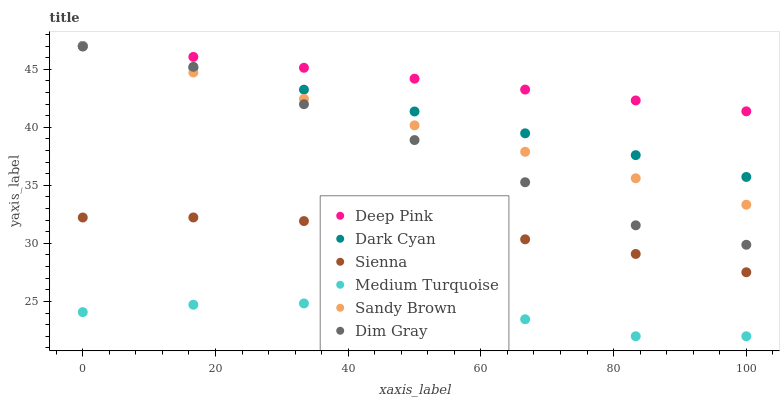Does Medium Turquoise have the minimum area under the curve?
Answer yes or no. Yes. Does Deep Pink have the maximum area under the curve?
Answer yes or no. Yes. Does Sienna have the minimum area under the curve?
Answer yes or no. No. Does Sienna have the maximum area under the curve?
Answer yes or no. No. Is Deep Pink the smoothest?
Answer yes or no. Yes. Is Dim Gray the roughest?
Answer yes or no. Yes. Is Sienna the smoothest?
Answer yes or no. No. Is Sienna the roughest?
Answer yes or no. No. Does Medium Turquoise have the lowest value?
Answer yes or no. Yes. Does Sienna have the lowest value?
Answer yes or no. No. Does Sandy Brown have the highest value?
Answer yes or no. Yes. Does Sienna have the highest value?
Answer yes or no. No. Is Sienna less than Dark Cyan?
Answer yes or no. Yes. Is Sandy Brown greater than Sienna?
Answer yes or no. Yes. Does Sandy Brown intersect Deep Pink?
Answer yes or no. Yes. Is Sandy Brown less than Deep Pink?
Answer yes or no. No. Is Sandy Brown greater than Deep Pink?
Answer yes or no. No. Does Sienna intersect Dark Cyan?
Answer yes or no. No. 